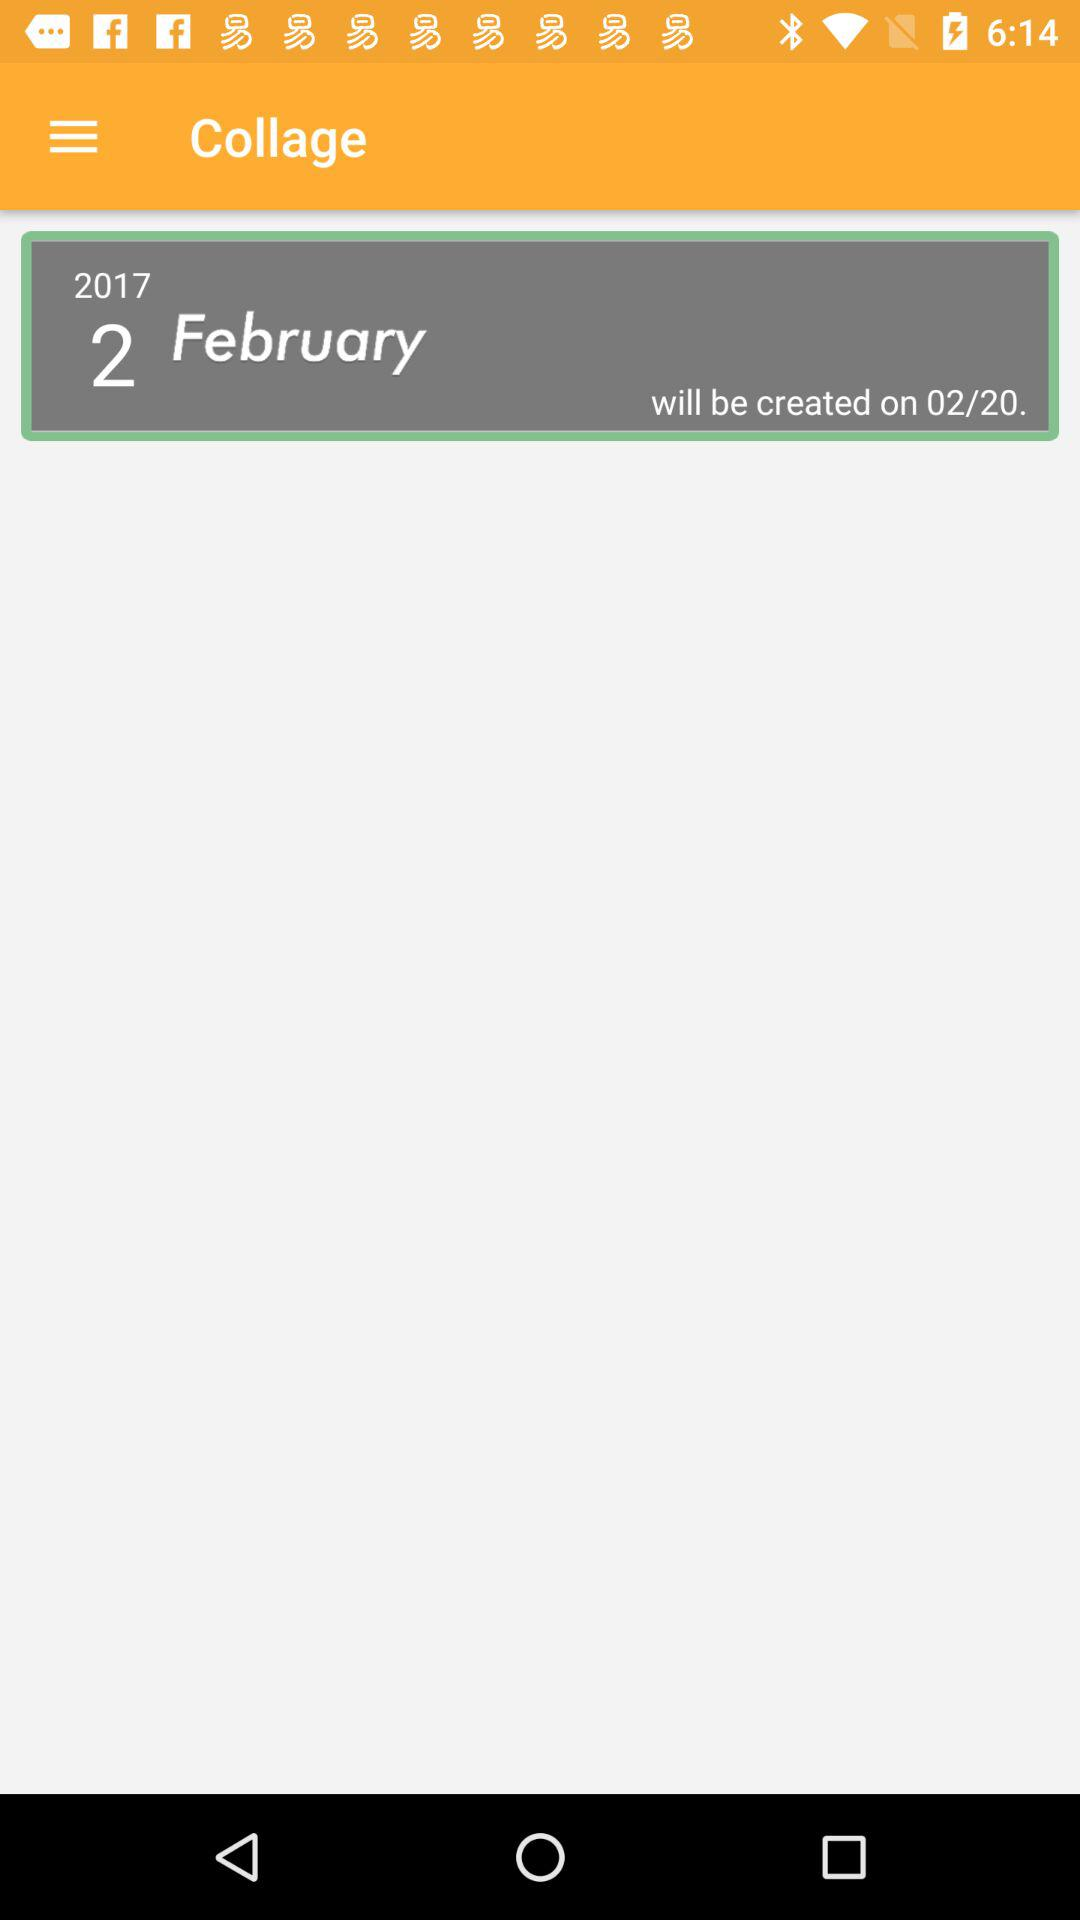What is the mentioned date? The mentioned dates are February 2, 2017 and February 20. 